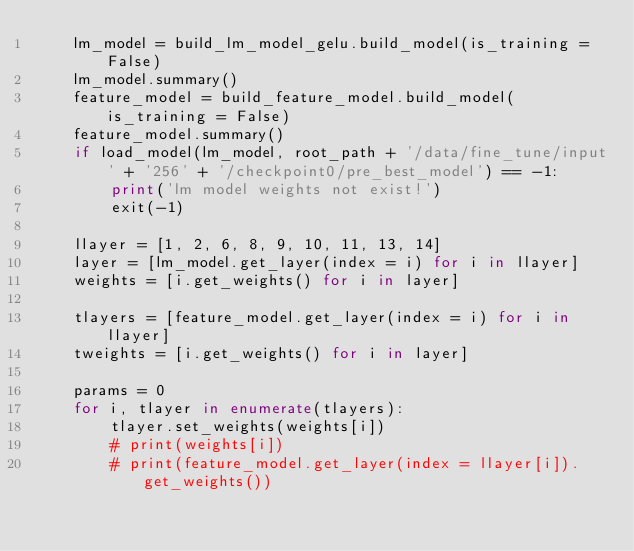Convert code to text. <code><loc_0><loc_0><loc_500><loc_500><_Python_>    lm_model = build_lm_model_gelu.build_model(is_training = False)
    lm_model.summary()
    feature_model = build_feature_model.build_model(is_training = False)
    feature_model.summary()
    if load_model(lm_model, root_path + '/data/fine_tune/input' + '256' + '/checkpoint0/pre_best_model') == -1:
        print('lm model weights not exist!')
        exit(-1)

    llayer = [1, 2, 6, 8, 9, 10, 11, 13, 14]
    layer = [lm_model.get_layer(index = i) for i in llayer]
    weights = [i.get_weights() for i in layer]

    tlayers = [feature_model.get_layer(index = i) for i in llayer]
    tweights = [i.get_weights() for i in layer]

    params = 0
    for i, tlayer in enumerate(tlayers):
        tlayer.set_weights(weights[i])
        # print(weights[i])
        # print(feature_model.get_layer(index = llayer[i]).get_weights())</code> 